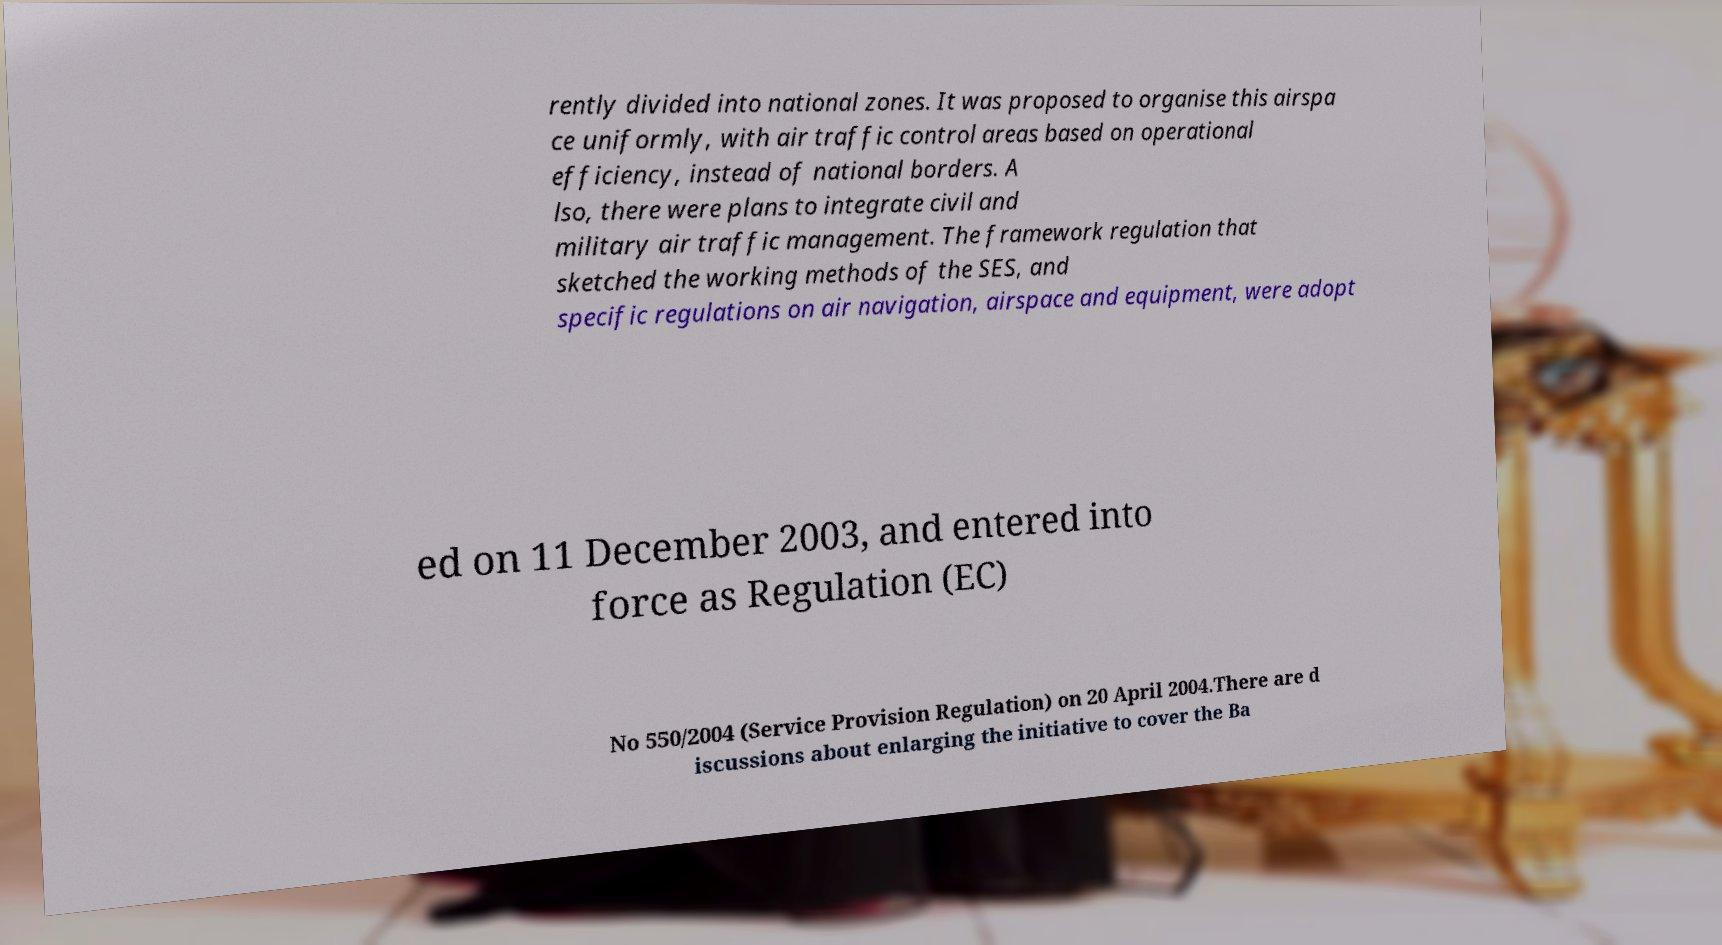I need the written content from this picture converted into text. Can you do that? rently divided into national zones. It was proposed to organise this airspa ce uniformly, with air traffic control areas based on operational efficiency, instead of national borders. A lso, there were plans to integrate civil and military air traffic management. The framework regulation that sketched the working methods of the SES, and specific regulations on air navigation, airspace and equipment, were adopt ed on 11 December 2003, and entered into force as Regulation (EC) No 550/2004 (Service Provision Regulation) on 20 April 2004.There are d iscussions about enlarging the initiative to cover the Ba 